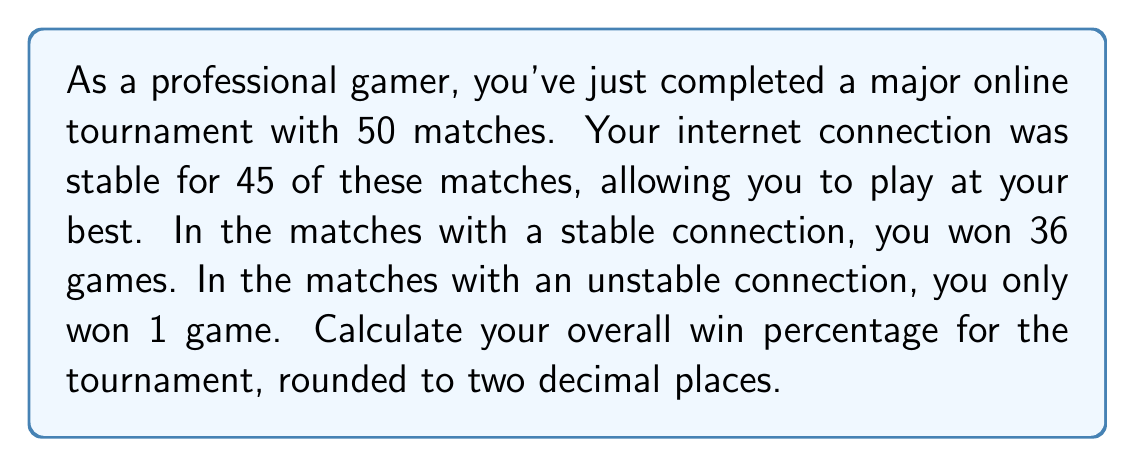Solve this math problem. Let's approach this step-by-step:

1) First, let's identify the key information:
   - Total matches: 50
   - Matches with stable connection: 45
   - Wins with stable connection: 36
   - Matches with unstable connection: 50 - 45 = 5
   - Wins with unstable connection: 1

2) Calculate total wins:
   $\text{Total wins} = \text{Wins with stable connection} + \text{Wins with unstable connection}$
   $\text{Total wins} = 36 + 1 = 37$

3) Calculate the win percentage:
   $\text{Win percentage} = \frac{\text{Total wins}}{\text{Total matches}} \times 100\%$

   $\text{Win percentage} = \frac{37}{50} \times 100\%$

4) Simplify the fraction:
   $\frac{37}{50} = 0.74$

5) Convert to percentage:
   $0.74 \times 100\% = 74\%$

Therefore, the overall win percentage for the tournament is 74.00%.
Answer: 74.00% 